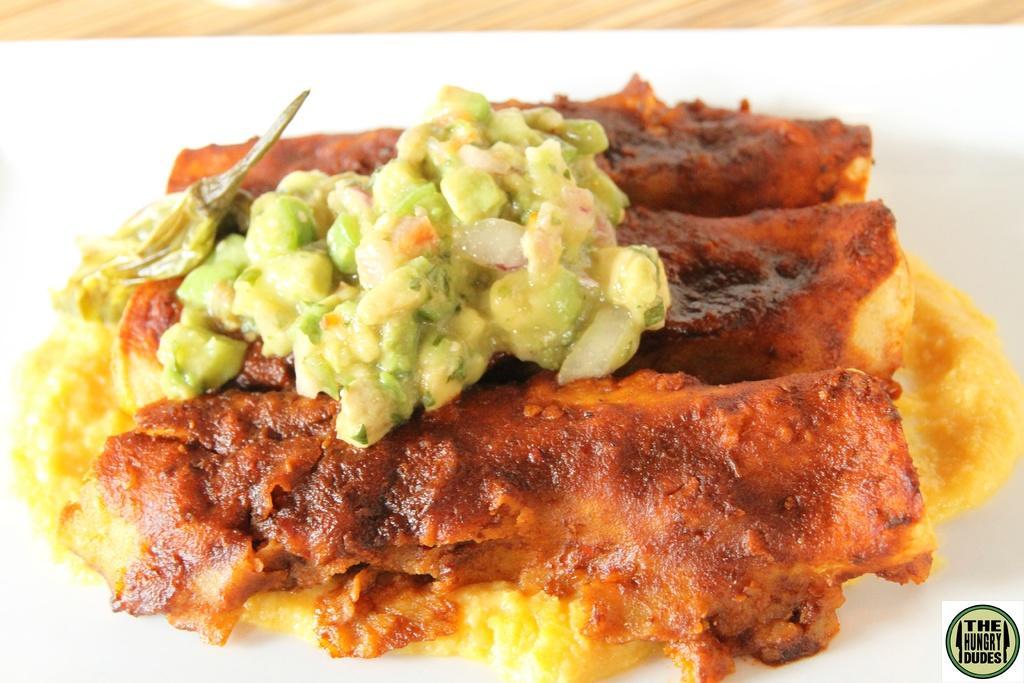Describe this image in one or two sentences. In this image I can see the food which is in red, yellow and green color. It is on the white surface. And I can see the brown color table in the back. 